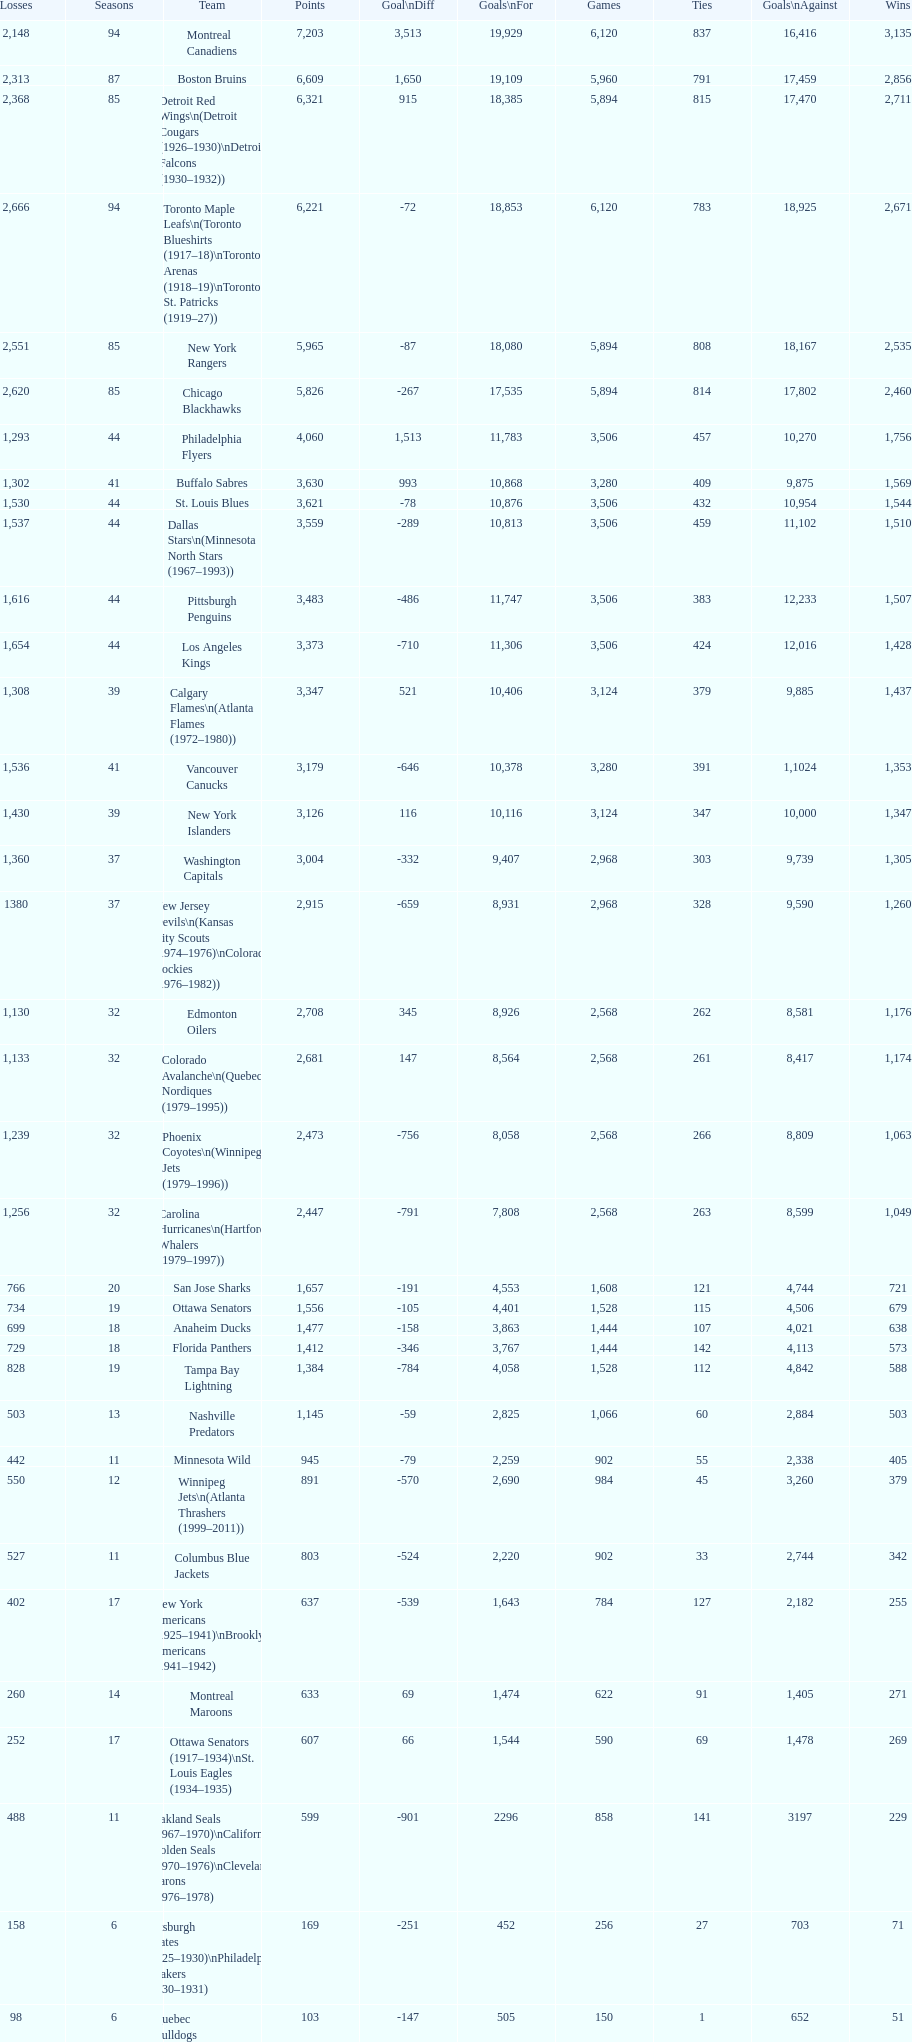How many losses do the st. louis blues have? 1,530. 